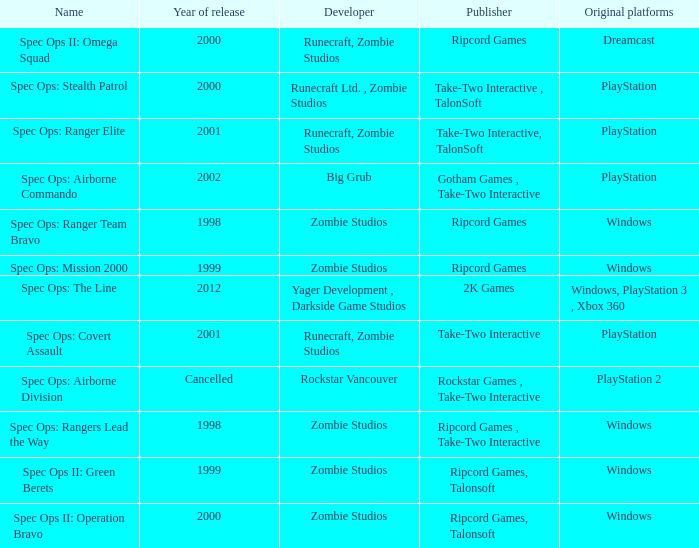Which developer has a year of cancelled releases? Rockstar Vancouver. Can you give me this table as a dict? {'header': ['Name', 'Year of release', 'Developer', 'Publisher', 'Original platforms'], 'rows': [['Spec Ops II: Omega Squad', '2000', 'Runecraft, Zombie Studios', 'Ripcord Games', 'Dreamcast'], ['Spec Ops: Stealth Patrol', '2000', 'Runecraft Ltd. , Zombie Studios', 'Take-Two Interactive , TalonSoft', 'PlayStation'], ['Spec Ops: Ranger Elite', '2001', 'Runecraft, Zombie Studios', 'Take-Two Interactive, TalonSoft', 'PlayStation'], ['Spec Ops: Airborne Commando', '2002', 'Big Grub', 'Gotham Games , Take-Two Interactive', 'PlayStation'], ['Spec Ops: Ranger Team Bravo', '1998', 'Zombie Studios', 'Ripcord Games', 'Windows'], ['Spec Ops: Mission 2000', '1999', 'Zombie Studios', 'Ripcord Games', 'Windows'], ['Spec Ops: The Line', '2012', 'Yager Development , Darkside Game Studios', '2K Games', 'Windows, PlayStation 3 , Xbox 360'], ['Spec Ops: Covert Assault', '2001', 'Runecraft, Zombie Studios', 'Take-Two Interactive', 'PlayStation'], ['Spec Ops: Airborne Division', 'Cancelled', 'Rockstar Vancouver', 'Rockstar Games , Take-Two Interactive', 'PlayStation 2'], ['Spec Ops: Rangers Lead the Way', '1998', 'Zombie Studios', 'Ripcord Games , Take-Two Interactive', 'Windows'], ['Spec Ops II: Green Berets', '1999', 'Zombie Studios', 'Ripcord Games, Talonsoft', 'Windows'], ['Spec Ops II: Operation Bravo', '2000', 'Zombie Studios', 'Ripcord Games, Talonsoft', 'Windows']]} 